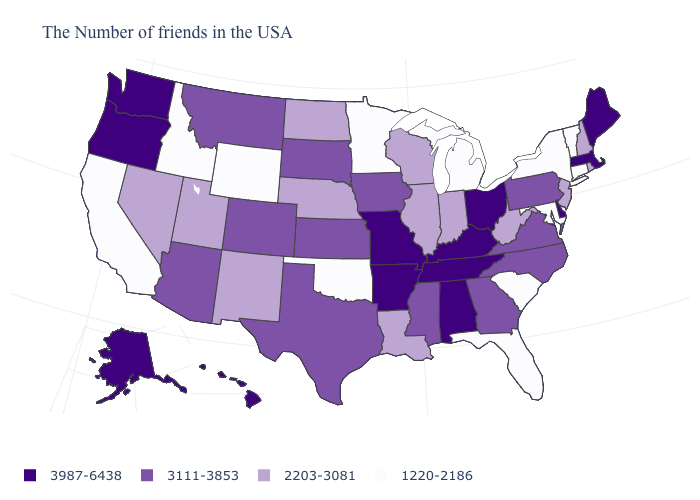What is the value of Oklahoma?
Keep it brief. 1220-2186. What is the value of Arizona?
Concise answer only. 3111-3853. Name the states that have a value in the range 2203-3081?
Short answer required. Rhode Island, New Hampshire, New Jersey, West Virginia, Indiana, Wisconsin, Illinois, Louisiana, Nebraska, North Dakota, New Mexico, Utah, Nevada. Name the states that have a value in the range 2203-3081?
Concise answer only. Rhode Island, New Hampshire, New Jersey, West Virginia, Indiana, Wisconsin, Illinois, Louisiana, Nebraska, North Dakota, New Mexico, Utah, Nevada. Does the first symbol in the legend represent the smallest category?
Quick response, please. No. Name the states that have a value in the range 2203-3081?
Give a very brief answer. Rhode Island, New Hampshire, New Jersey, West Virginia, Indiana, Wisconsin, Illinois, Louisiana, Nebraska, North Dakota, New Mexico, Utah, Nevada. Among the states that border Nevada , does Oregon have the highest value?
Write a very short answer. Yes. Which states have the highest value in the USA?
Short answer required. Maine, Massachusetts, Delaware, Ohio, Kentucky, Alabama, Tennessee, Missouri, Arkansas, Washington, Oregon, Alaska, Hawaii. What is the value of Colorado?
Write a very short answer. 3111-3853. Name the states that have a value in the range 3987-6438?
Quick response, please. Maine, Massachusetts, Delaware, Ohio, Kentucky, Alabama, Tennessee, Missouri, Arkansas, Washington, Oregon, Alaska, Hawaii. Does Washington have a higher value than Hawaii?
Quick response, please. No. Does Massachusetts have the same value as Alabama?
Be succinct. Yes. What is the lowest value in states that border New Jersey?
Concise answer only. 1220-2186. What is the value of Ohio?
Answer briefly. 3987-6438. Name the states that have a value in the range 3111-3853?
Concise answer only. Pennsylvania, Virginia, North Carolina, Georgia, Mississippi, Iowa, Kansas, Texas, South Dakota, Colorado, Montana, Arizona. 